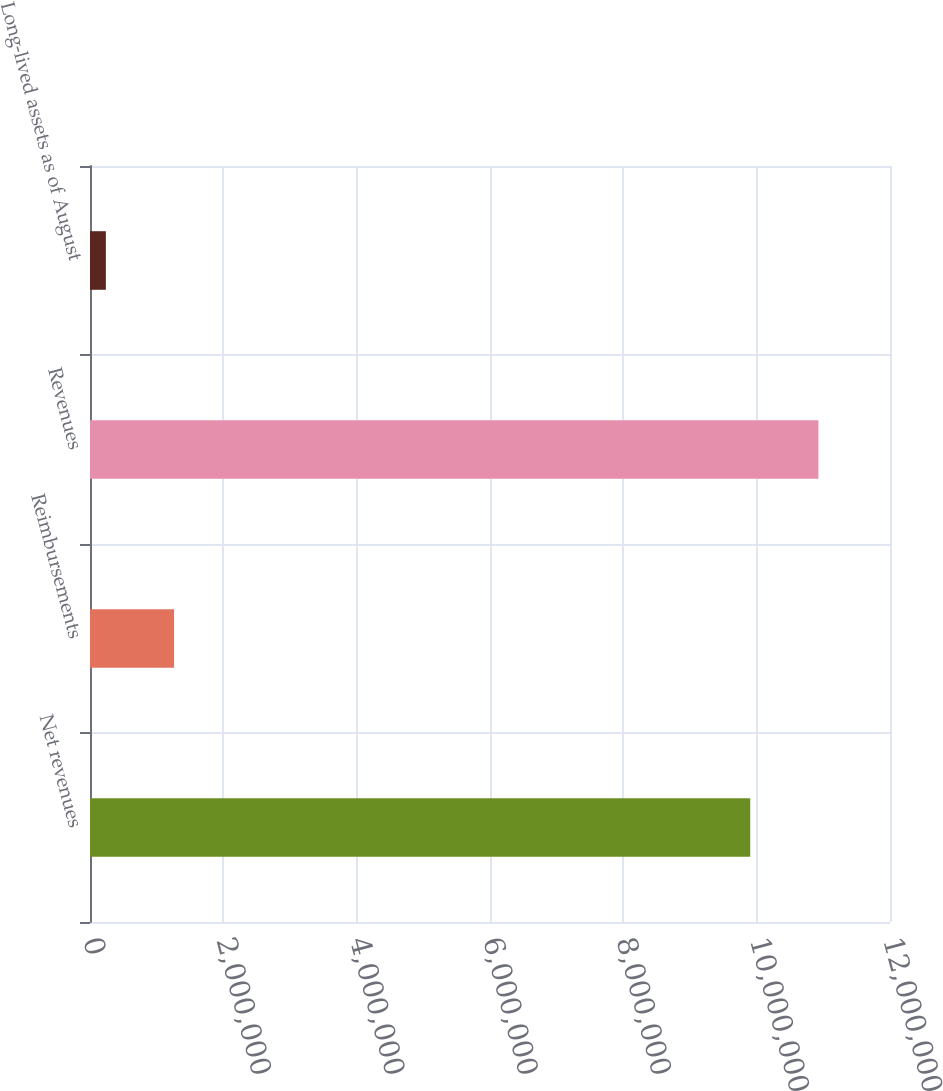Convert chart to OTSL. <chart><loc_0><loc_0><loc_500><loc_500><bar_chart><fcel>Net revenues<fcel>Reimbursements<fcel>Revenues<fcel>Long-lived assets as of August<nl><fcel>9.90354e+06<fcel>1.2609e+06<fcel>1.09266e+07<fcel>237845<nl></chart> 